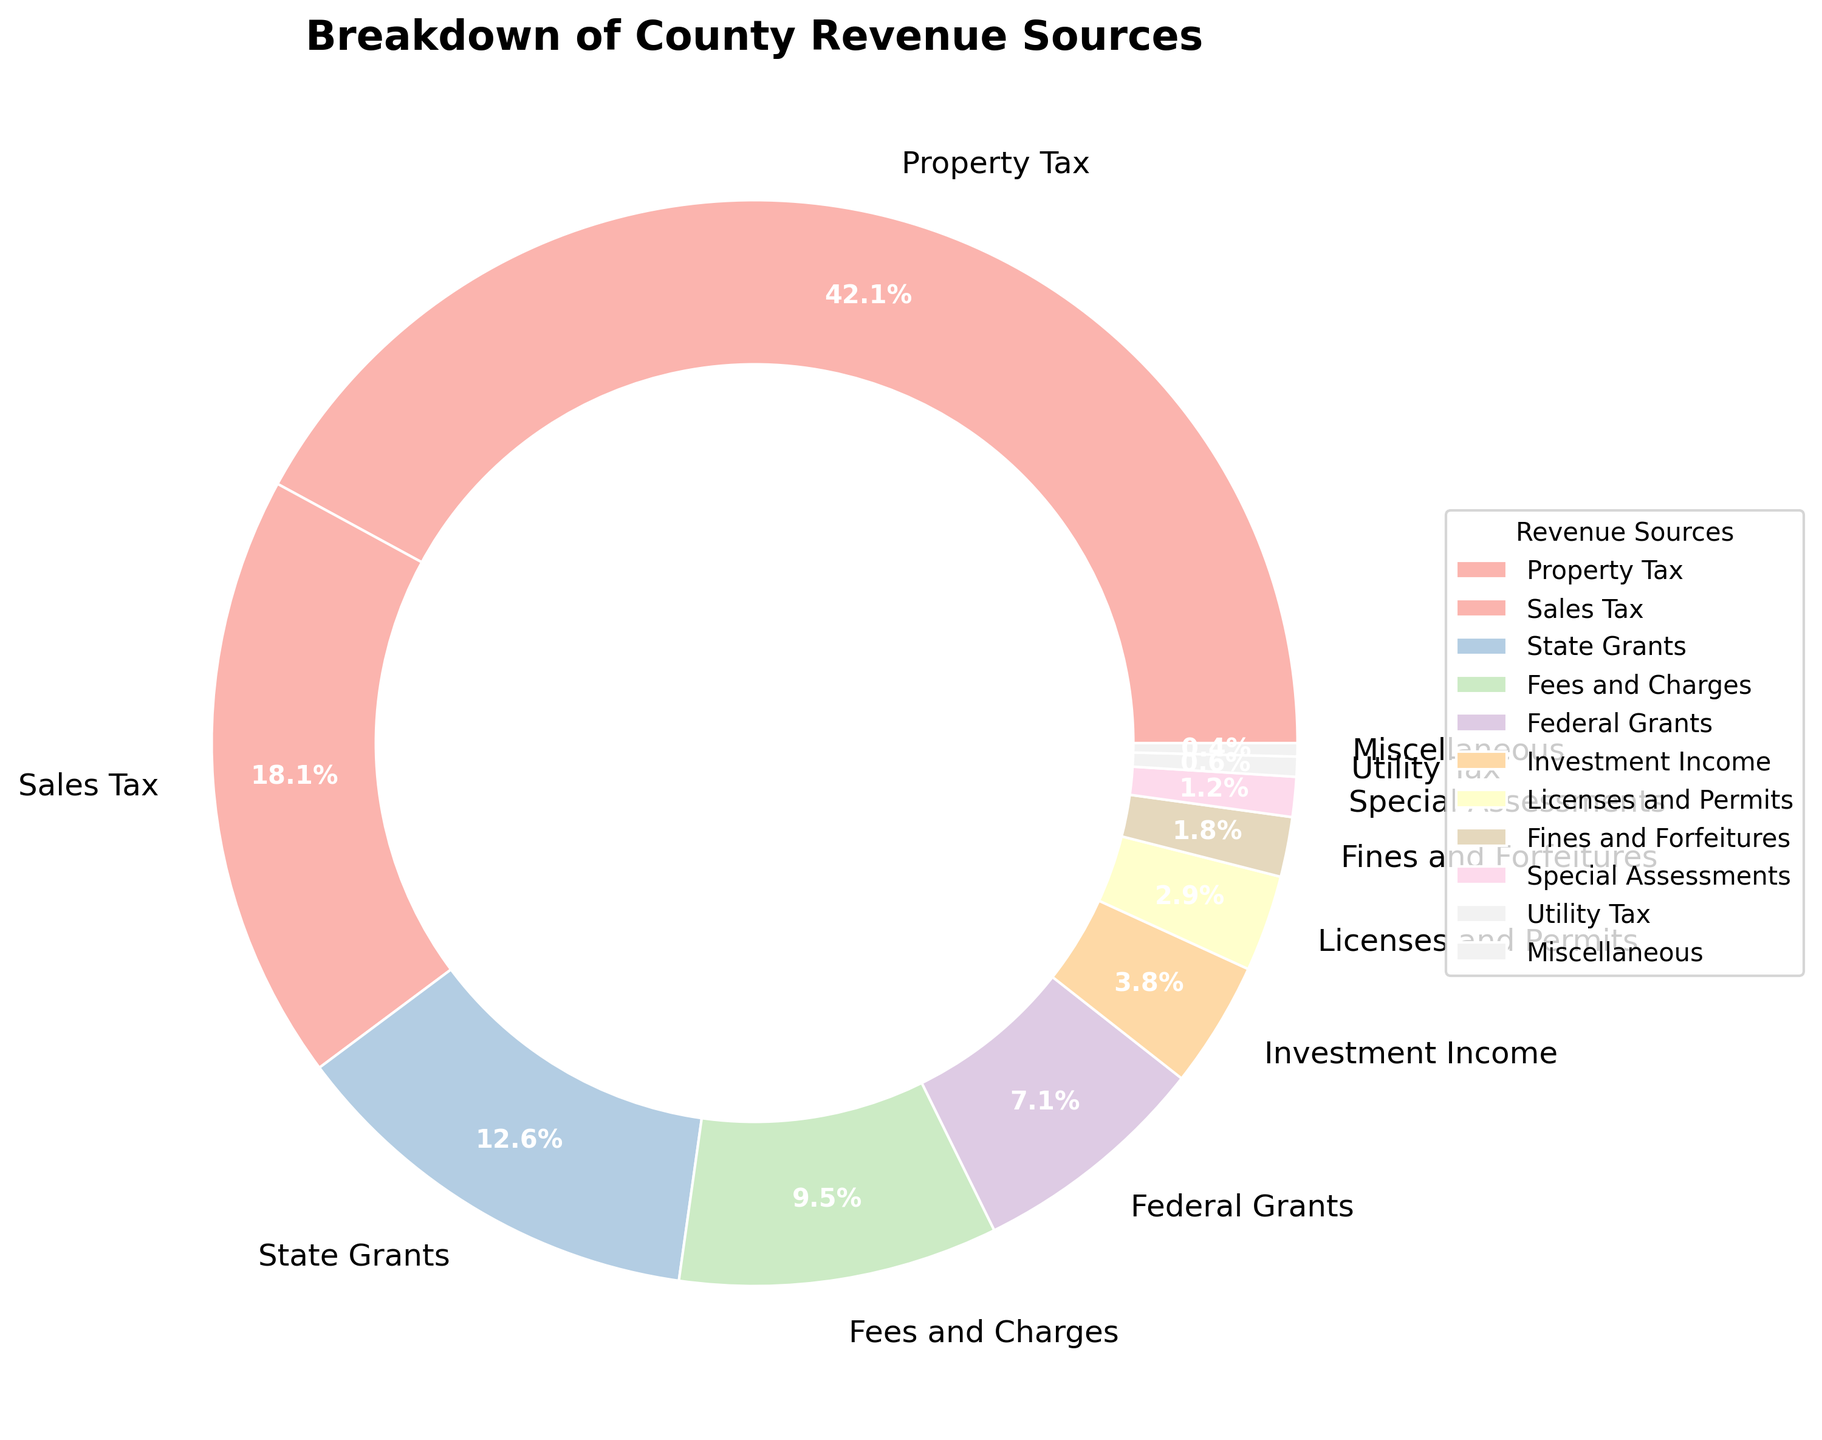What's the largest revenue source for the county? The largest revenue source is the one with the highest percentage value in the pie chart. In this case, it’s Property Tax, which is 42.5%.
Answer: Property Tax How much more percentage does Property Tax contribute compared to Sales Tax? Subtract the percentage for Sales Tax from the percentage for Property Tax: 42.5% - 18.3% = 24.2%.
Answer: 24.2% Which revenue sources contribute less than 5% to the total revenue? Identify the slices in the pie chart that have a percentage value less than 5%. These are: Investment Income (3.8%), Licenses and Permits (2.9%), Fines and Forfeitures (1.8%), Special Assessments (1.2%), Utility Tax (0.6%), and Miscellaneous (0.4%).
Answer: Investment Income, Licenses and Permits, Fines and Forfeitures, Special Assessments, Utility Tax, Miscellaneous What percentage of revenue comes from grants (state and federal combined)? Sum the percentage values for State Grants and Federal Grants: 12.7% + 7.2% = 19.9%.
Answer: 19.9% Which revenue source has the smallest contribution? The smallest contribution is indicated by the smallest slice in the pie chart. In this case, it's Miscellaneous, which is 0.4%.
Answer: Miscellaneous What’s the combined contribution of Sales Tax, Fees and Charges, and Licenses and Permits? Sum the percentage values for these revenue sources: 18.3% + 9.6% + 2.9% = 30.8%.
Answer: 30.8% Which revenue sources contribute less than Sales Tax but more than Fines and Forfeitures? Identify the slices with percentage values between Sales Tax (18.3%) and Fines and Forfeitures (1.8%). These are: State Grants (12.7%), Fees and Charges (9.6%), Federal Grants (7.2%), Investment Income (3.8%), and Licenses and Permits (2.9%).
Answer: State Grants, Fees and Charges, Federal Grants, Investment Income, Licenses and Permits Compare the percentage of Federal Grants to Utility Tax. Which contributes more and by how much? Federal Grants contribute more than Utility Tax. Subtract the percentage of Utility Tax from Federal Grants: 7.2% - 0.6% = 6.6%.
Answer: Federal Grants by 6.6% If one were to create a revenue source category named "Taxes" combining Property Tax, Sales Tax, and Utility Tax, what would be the total percentage for this category? Sum the percentage values for Property Tax, Sales Tax, and Utility Tax: 42.5% + 18.3% + 0.6% = 61.4%.
Answer: 61.4% Of the non-tax revenue sources, which one contributes the most? Identify non-tax revenue sources and find the one with the highest percentage. The non-tax sources are State Grants (12.7%), Fees and Charges (9.6%), Federal Grants (7.2%), Investment Income (3.8%), Licenses and Permits (2.9%), Fines and Forfeitures (1.8%), Special Assessments (1.2%), Miscellaneous (0.4%). The highest among these is State Grants with 12.7%.
Answer: State Grants 